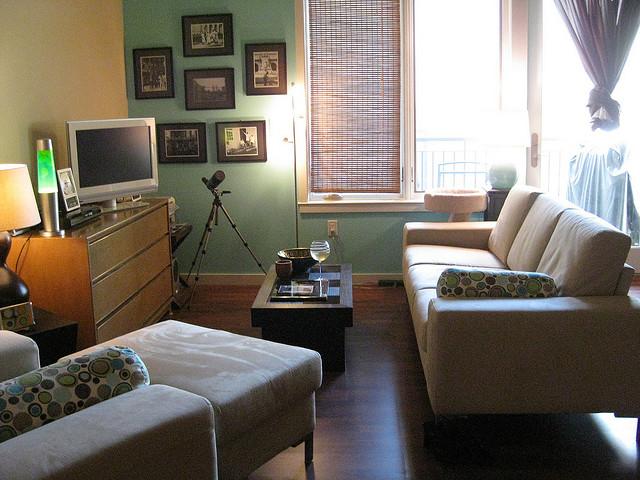Where is the white wine?
Give a very brief answer. On coffee table. How many photos are on the green wall?
Be succinct. 6. What color is the lava lamp?
Answer briefly. Green. 